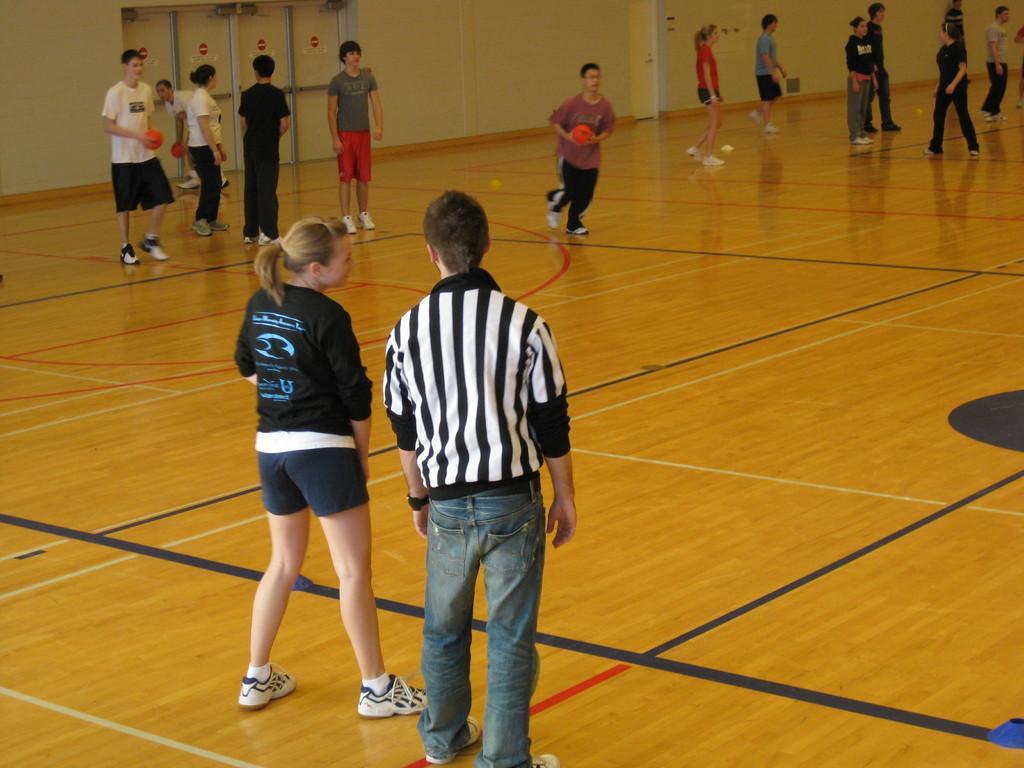In one or two sentences, can you explain what this image depicts? In this image we can see people playing a game and some of them are holding balls. In the background there is a wall. 